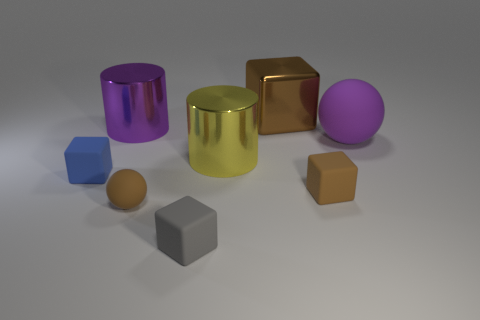Add 2 small gray blocks. How many objects exist? 10 Subtract all cylinders. How many objects are left? 6 Add 5 purple matte things. How many purple matte things are left? 6 Add 3 green objects. How many green objects exist? 3 Subtract 0 gray balls. How many objects are left? 8 Subtract all tiny gray balls. Subtract all blue objects. How many objects are left? 7 